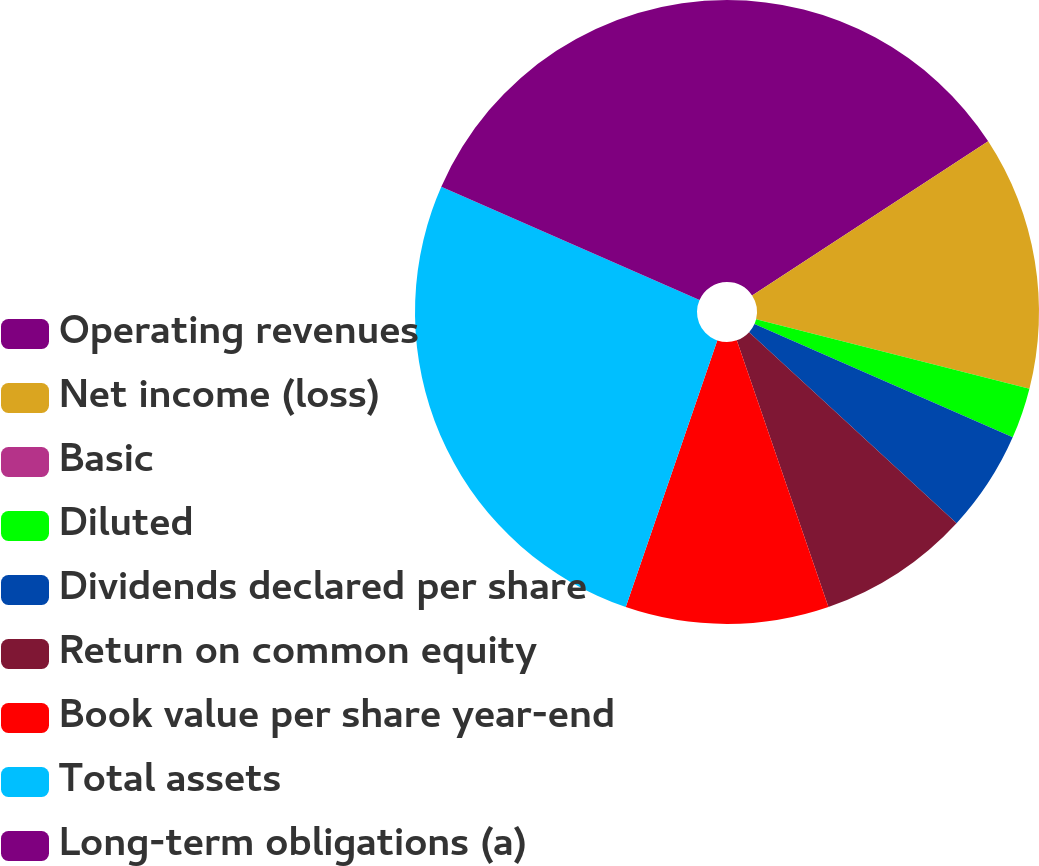Convert chart to OTSL. <chart><loc_0><loc_0><loc_500><loc_500><pie_chart><fcel>Operating revenues<fcel>Net income (loss)<fcel>Basic<fcel>Diluted<fcel>Dividends declared per share<fcel>Return on common equity<fcel>Book value per share year-end<fcel>Total assets<fcel>Long-term obligations (a)<nl><fcel>15.79%<fcel>13.16%<fcel>0.0%<fcel>2.63%<fcel>5.26%<fcel>7.89%<fcel>10.53%<fcel>26.32%<fcel>18.42%<nl></chart> 